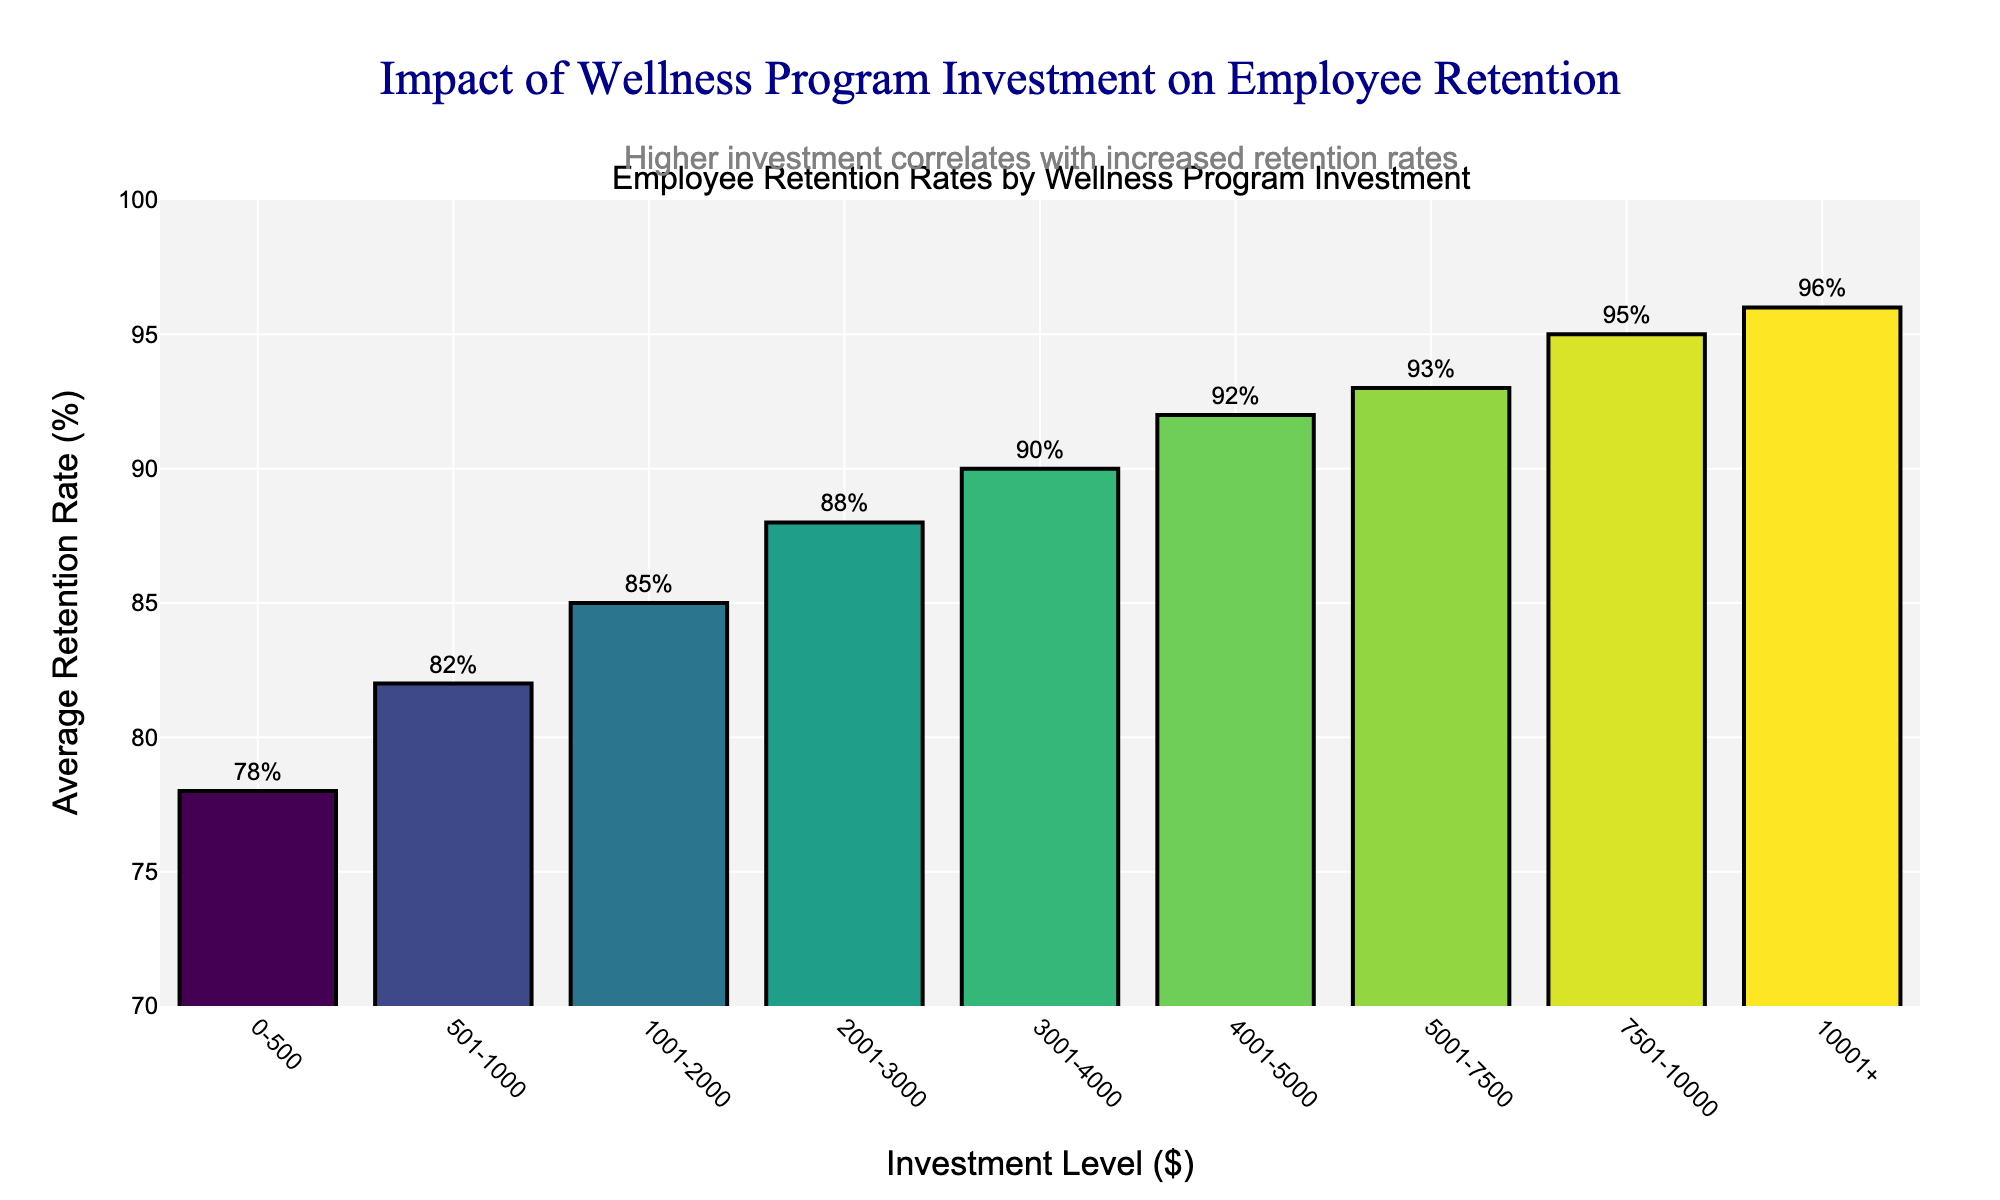Which investment level has the highest average retention rate? Look at the bar chart to identify the bar with the highest height. The bar corresponding to the investment level "10001+" has the highest average retention rate.
Answer: 10001+ What is the difference in average retention rate between the investment levels of 501-1000 and 7501-10000? Identify the retention rates for the specified investment levels: 82% for 501-1000 and 95% for 7501-10000. Subtract the smaller retention rate from the larger: 95% - 82% = 13%.
Answer: 13% Which investment level shows an average retention rate of 90%? Find the bar that corresponds to an average retention rate of 90%. This retention rate is associated with the investment level of 3001-4000.
Answer: 3001-4000 What is the average retention rate for investment levels between 2001 and 5000? Identify the retention rates for investment levels 2001-3000, 3001-4000, and 4001-5000: 88%, 90%, and 92% respectively. Calculate the average: (88% + 90% + 92%) / 3 = 90%.
Answer: 90% By how much does the average retention rate increase from the lowest to the highest investment level? Find the retention rates for the lowest (0-500) and highest (10001+) investment levels: 78% and 96% respectively. Subtract the lower from the higher: 96% - 78% = 18%.
Answer: 18% Is the average retention rate for investments between 0-500 higher than for investments between 1001-2000? Identify the retention rates for 0-500 and 1001-2000 levels: 78% for 0-500 and 85% for 1001-2000. Compare the two values: 78% is not higher than 85%.
Answer: No How does the retention rate change as the investment level increases from 5001-7500 to 7501-10000? Identify the retention rates for the two investment levels: 93% for 5001-7500 and 95% for 7501-10000. The retention rate increases by 2% (95% - 93%).
Answer: 2% What is the overall trend in employee retention rates with increasing investment in wellness programs? Observe the heights of the bars as you move from left to right across the investment levels. The trend shows that employee retention rates increase as investment in wellness programs increases.
Answer: Increases Which investment level has an average retention rate of 82%? Identify the bar labeled with an 82% retention rate. This corresponds to the investment level of 501-1000.
Answer: 501-1000 